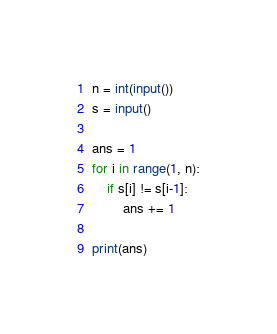Convert code to text. <code><loc_0><loc_0><loc_500><loc_500><_Python_>n = int(input())
s = input()

ans = 1
for i in range(1, n):
    if s[i] != s[i-1]:
        ans += 1

print(ans)
</code> 